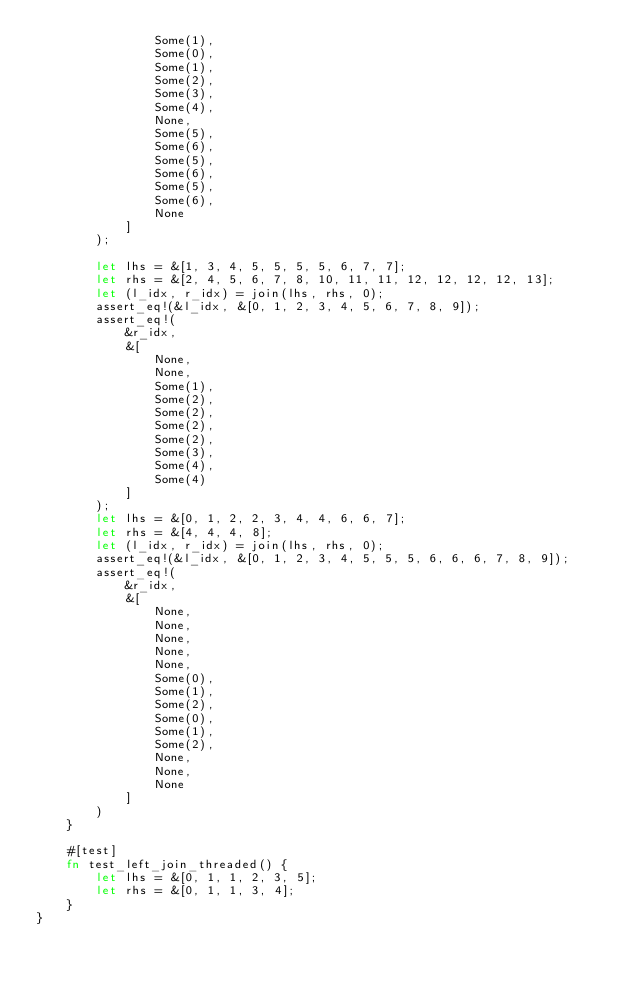Convert code to text. <code><loc_0><loc_0><loc_500><loc_500><_Rust_>                Some(1),
                Some(0),
                Some(1),
                Some(2),
                Some(3),
                Some(4),
                None,
                Some(5),
                Some(6),
                Some(5),
                Some(6),
                Some(5),
                Some(6),
                None
            ]
        );

        let lhs = &[1, 3, 4, 5, 5, 5, 5, 6, 7, 7];
        let rhs = &[2, 4, 5, 6, 7, 8, 10, 11, 11, 12, 12, 12, 12, 13];
        let (l_idx, r_idx) = join(lhs, rhs, 0);
        assert_eq!(&l_idx, &[0, 1, 2, 3, 4, 5, 6, 7, 8, 9]);
        assert_eq!(
            &r_idx,
            &[
                None,
                None,
                Some(1),
                Some(2),
                Some(2),
                Some(2),
                Some(2),
                Some(3),
                Some(4),
                Some(4)
            ]
        );
        let lhs = &[0, 1, 2, 2, 3, 4, 4, 6, 6, 7];
        let rhs = &[4, 4, 4, 8];
        let (l_idx, r_idx) = join(lhs, rhs, 0);
        assert_eq!(&l_idx, &[0, 1, 2, 3, 4, 5, 5, 5, 6, 6, 6, 7, 8, 9]);
        assert_eq!(
            &r_idx,
            &[
                None,
                None,
                None,
                None,
                None,
                Some(0),
                Some(1),
                Some(2),
                Some(0),
                Some(1),
                Some(2),
                None,
                None,
                None
            ]
        )
    }

    #[test]
    fn test_left_join_threaded() {
        let lhs = &[0, 1, 1, 2, 3, 5];
        let rhs = &[0, 1, 1, 3, 4];
    }
}
</code> 